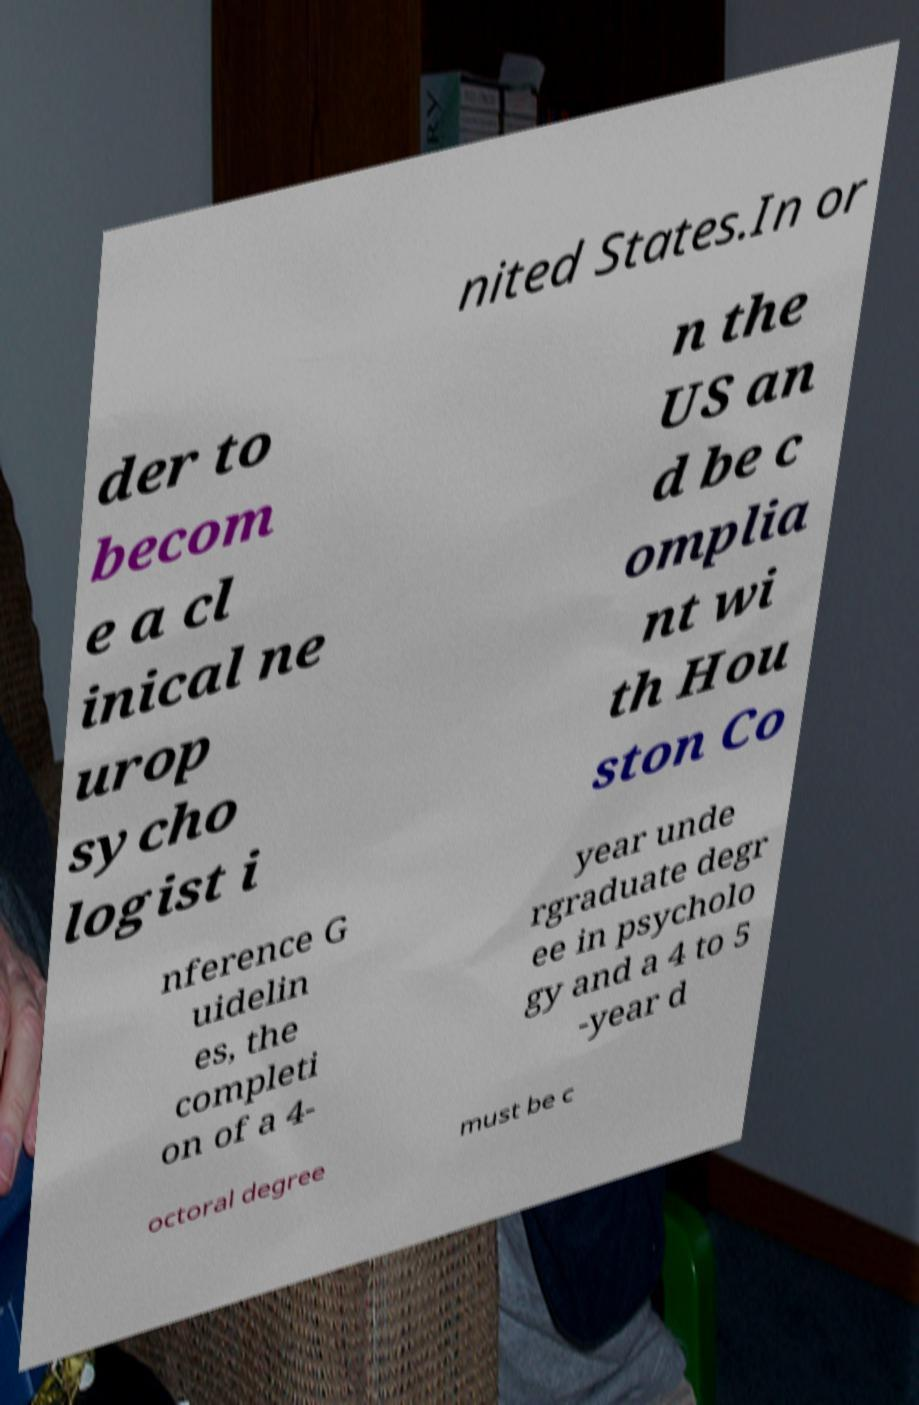Can you read and provide the text displayed in the image?This photo seems to have some interesting text. Can you extract and type it out for me? nited States.In or der to becom e a cl inical ne urop sycho logist i n the US an d be c omplia nt wi th Hou ston Co nference G uidelin es, the completi on of a 4- year unde rgraduate degr ee in psycholo gy and a 4 to 5 -year d octoral degree must be c 